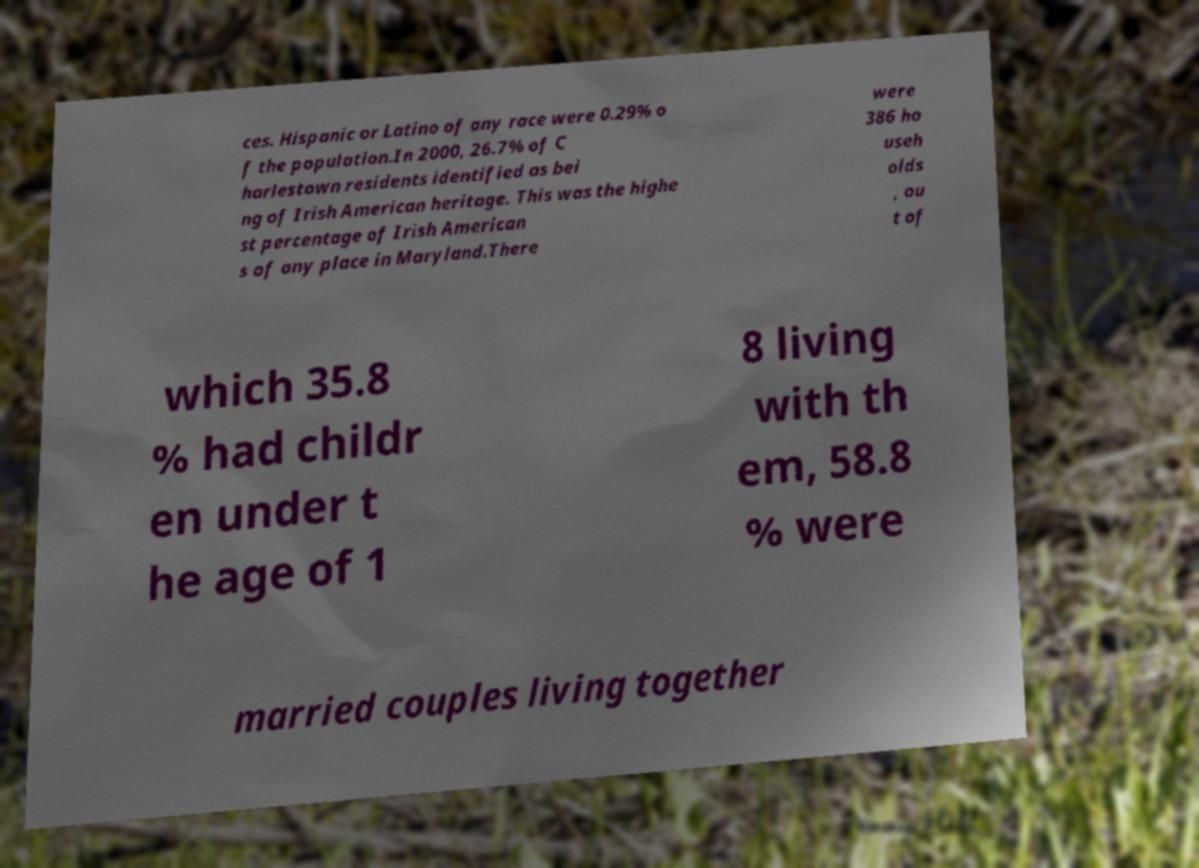What messages or text are displayed in this image? I need them in a readable, typed format. ces. Hispanic or Latino of any race were 0.29% o f the population.In 2000, 26.7% of C harlestown residents identified as bei ng of Irish American heritage. This was the highe st percentage of Irish American s of any place in Maryland.There were 386 ho useh olds , ou t of which 35.8 % had childr en under t he age of 1 8 living with th em, 58.8 % were married couples living together 